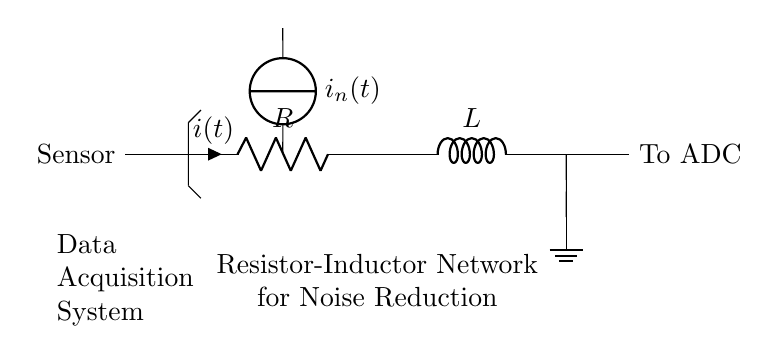What type of network is represented in this circuit? The circuit represents a Resistor-Inductor network, as indicated by the R and L components connected in series.
Answer: Resistor-Inductor What does the noise current source represent? The noise current source represents unwanted electrical noise that affects the sensor signal, shown as 'i_n(t)' feeding into the circuit.
Answer: Unwanted noise What is the output of this circuit connected to? The output of this circuit is connected to an Analog-to-Digital Converter (ADC), which is indicated by the label 'To ADC' in the diagram.
Answer: To ADC How does the Resistor-Inductor network help in data acquisition? The Resistor-Inductor network filters out noise from the sensor signal, allowing for a cleaner signal to be digitized by the ADC, improving data quality.
Answer: Filters noise What is the role of the resistor in this circuit? The resistor limits the current flowing through the circuit and dissipates energy as heat, which is essential for controlling the signal levels in noise reduction.
Answer: Limits current What happens to the inductance in high frequencies? In high frequencies, the inductor acts as an open circuit, significantly reducing the impact of high-frequency noise on the sensor signal.
Answer: Acts as open circuit How does this network affect signal integrity? The resistor-inductor network enhances signal integrity by attenuating high-frequency noise, thus preserving the desired sensor signal for accurate readings.
Answer: Enhances signal integrity 